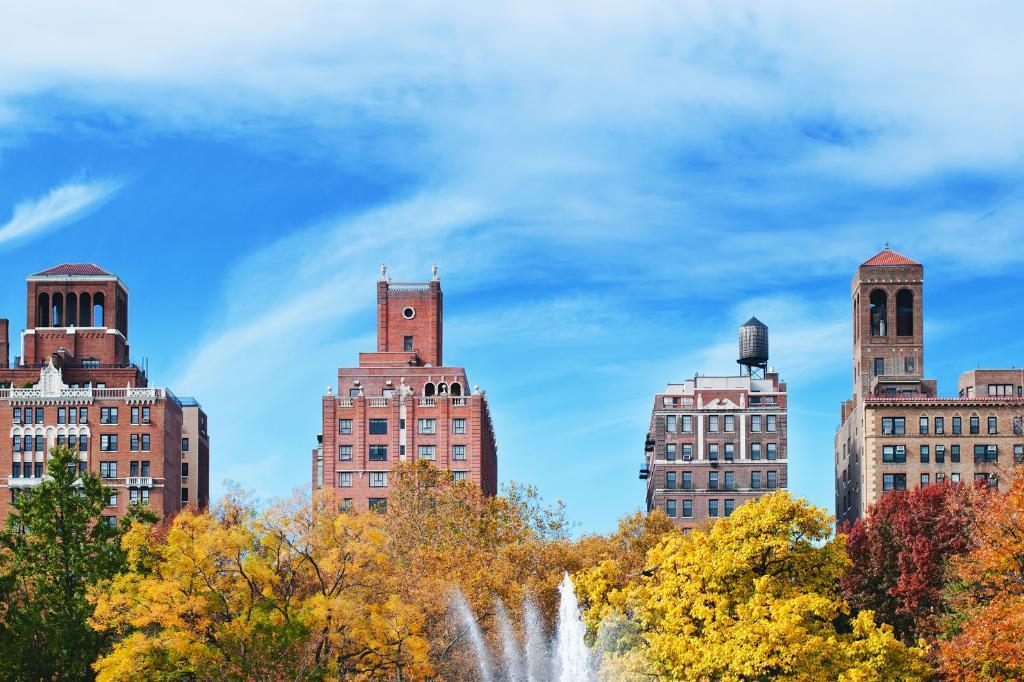Please provide a concise description of this image. In the image we can see there are many buildings and these are the windows of the buildings. There are even trees of different colors. There is even water and a cloudy pale blue sky. 